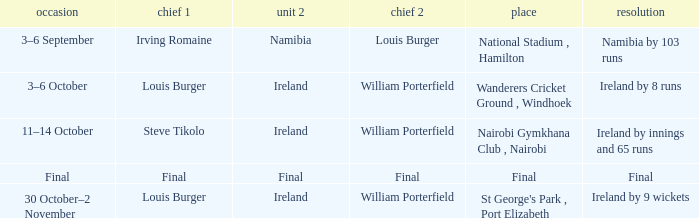Which Team 2 has a Captain 1 of final? Final. 